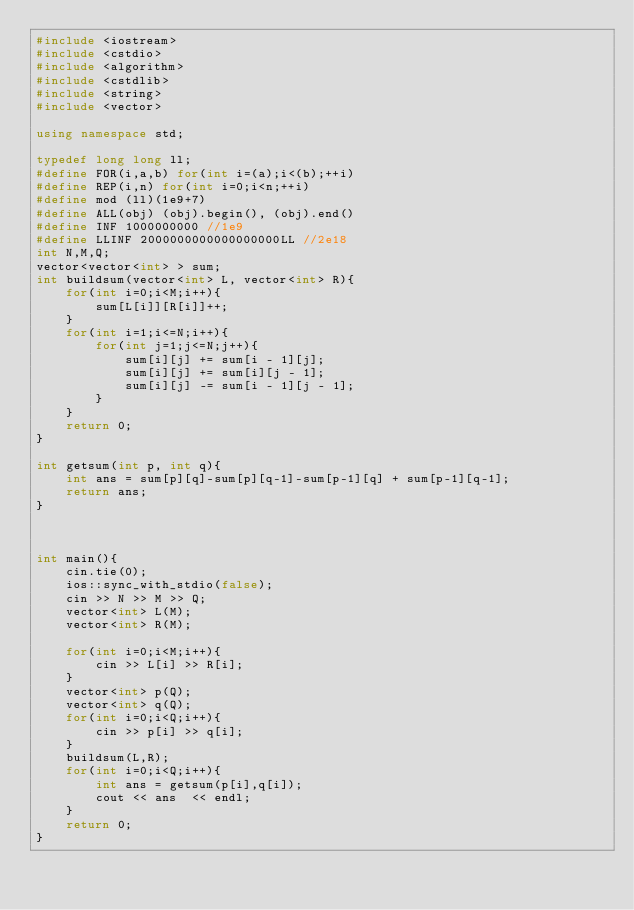Convert code to text. <code><loc_0><loc_0><loc_500><loc_500><_C++_>#include <iostream>
#include <cstdio>
#include <algorithm>
#include <cstdlib>
#include <string>
#include <vector>

using namespace std;

typedef long long ll;
#define FOR(i,a,b) for(int i=(a);i<(b);++i)
#define REP(i,n) for(int i=0;i<n;++i)
#define mod (ll)(1e9+7)
#define ALL(obj) (obj).begin(), (obj).end()
#define INF 1000000000 //1e9
#define LLINF 2000000000000000000LL //2e18
int N,M,Q;
vector<vector<int> > sum;
int buildsum(vector<int> L, vector<int> R){
    for(int i=0;i<M;i++){
        sum[L[i]][R[i]]++;
    }
    for(int i=1;i<=N;i++){
        for(int j=1;j<=N;j++){
            sum[i][j] += sum[i - 1][j];
			sum[i][j] += sum[i][j - 1];
			sum[i][j] -= sum[i - 1][j - 1];
        }
    }
    return 0;
}

int getsum(int p, int q){
    int ans = sum[p][q]-sum[p][q-1]-sum[p-1][q] + sum[p-1][q-1];
    return ans;
}



int main(){
    cin.tie(0);
    ios::sync_with_stdio(false);
    cin >> N >> M >> Q;
    vector<int> L(M);
    vector<int> R(M);
    
    for(int i=0;i<M;i++){
        cin >> L[i] >> R[i];
    }
    vector<int> p(Q);
    vector<int> q(Q);
    for(int i=0;i<Q;i++){
        cin >> p[i] >> q[i];
    }
    buildsum(L,R);
    for(int i=0;i<Q;i++){
        int ans = getsum(p[i],q[i]);
        cout << ans  << endl;
    }
    return 0;
}</code> 